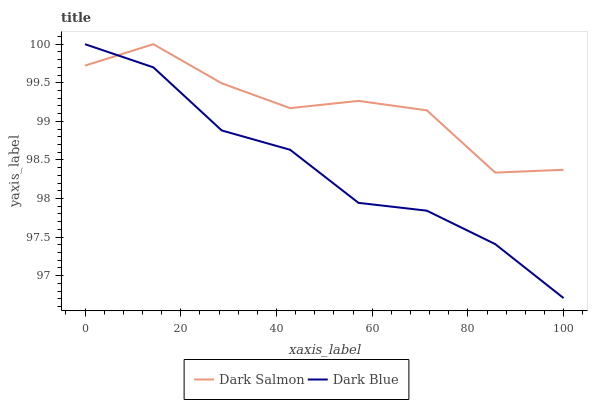Does Dark Blue have the minimum area under the curve?
Answer yes or no. Yes. Does Dark Salmon have the maximum area under the curve?
Answer yes or no. Yes. Does Dark Salmon have the minimum area under the curve?
Answer yes or no. No. Is Dark Blue the smoothest?
Answer yes or no. Yes. Is Dark Salmon the roughest?
Answer yes or no. Yes. Is Dark Salmon the smoothest?
Answer yes or no. No. Does Dark Blue have the lowest value?
Answer yes or no. Yes. Does Dark Salmon have the lowest value?
Answer yes or no. No. Does Dark Salmon have the highest value?
Answer yes or no. Yes. Does Dark Blue intersect Dark Salmon?
Answer yes or no. Yes. Is Dark Blue less than Dark Salmon?
Answer yes or no. No. Is Dark Blue greater than Dark Salmon?
Answer yes or no. No. 